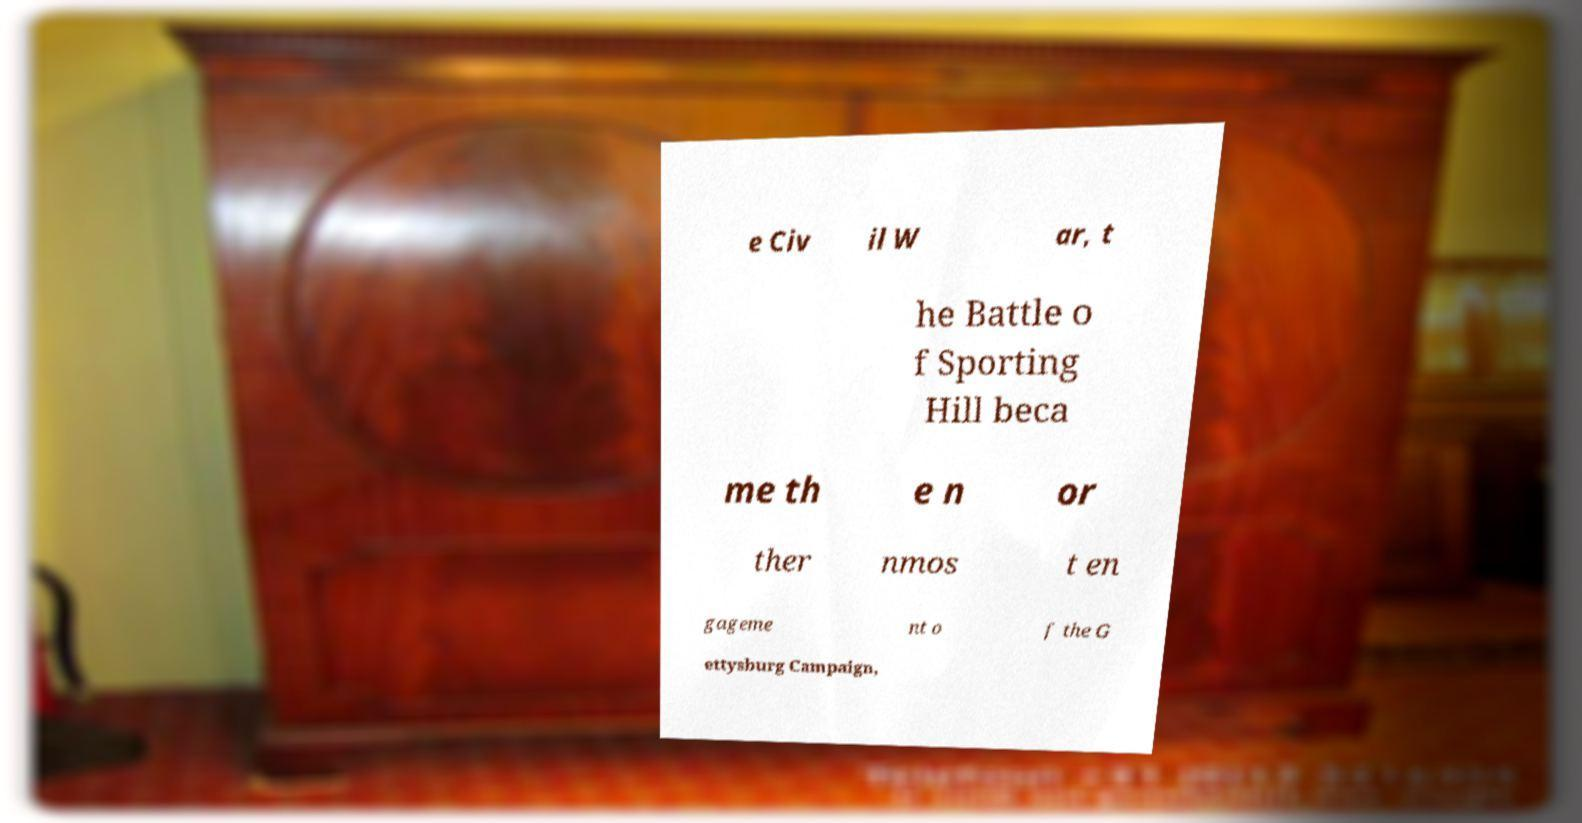Please read and relay the text visible in this image. What does it say? e Civ il W ar, t he Battle o f Sporting Hill beca me th e n or ther nmos t en gageme nt o f the G ettysburg Campaign, 